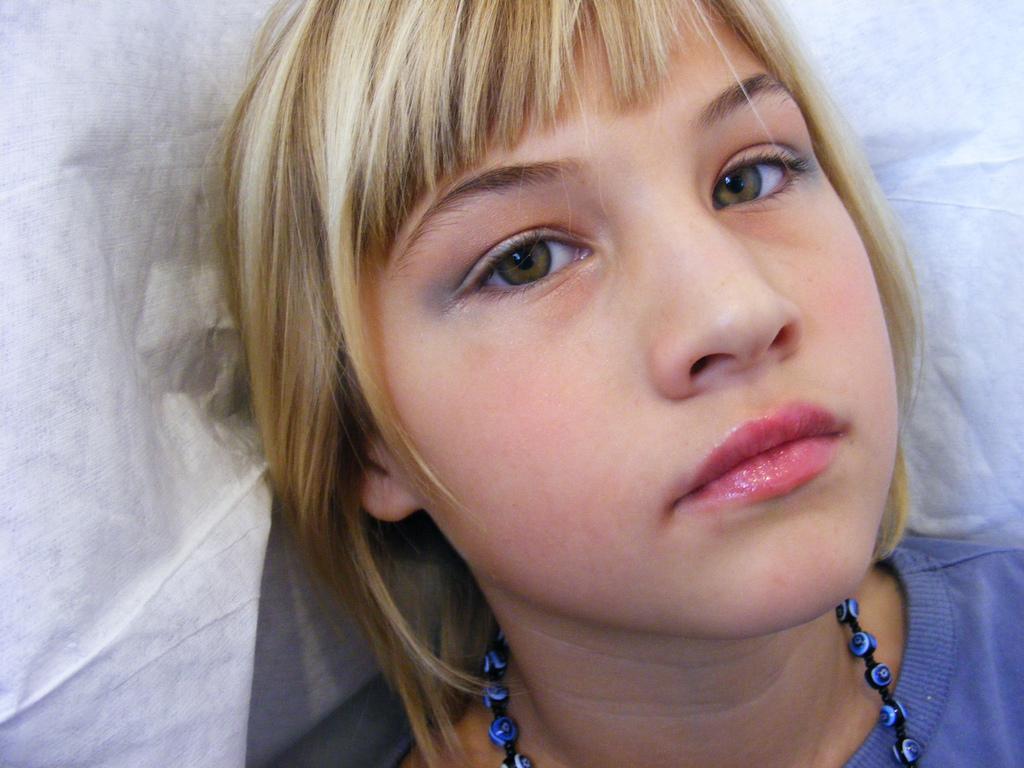Describe this image in one or two sentences. In this image, we can see a girl and the background is white in color. 